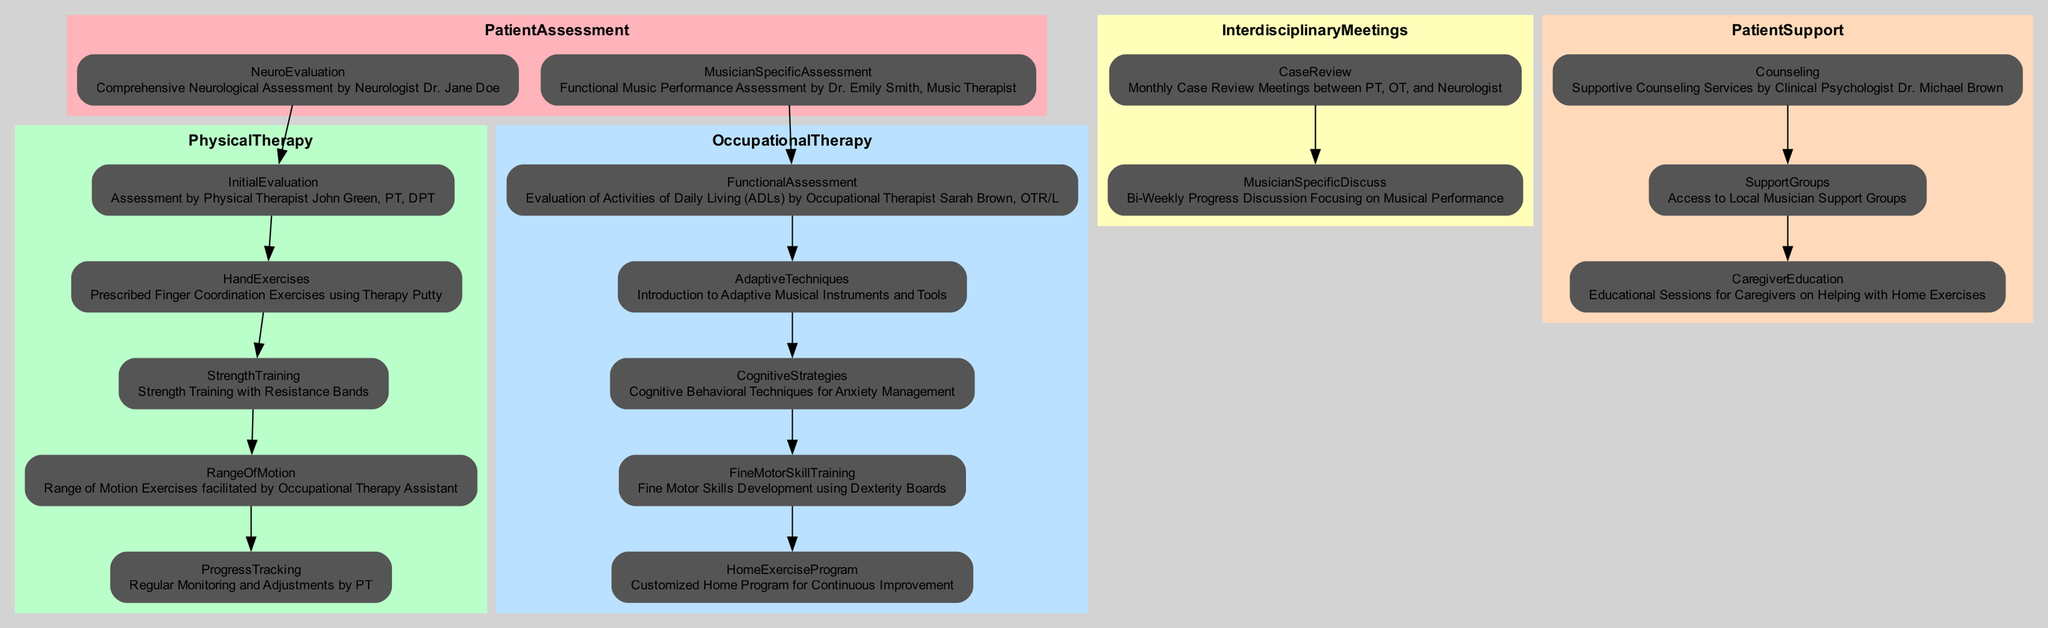What is the first assessment for a patient? The diagram shows the node "NeuroEvaluation" under "PatientAssessment," indicating that the first assessment is a Comprehensive Neurological Assessment by Neurologist Dr. Jane Doe.
Answer: Comprehensive Neurological Assessment by Neurologist Dr. Jane Doe Who conducts the initial evaluation for physical therapy? The diagram identifies "Physical Therapist John Green, PT, DPT" under "InitialEvaluation," showing that he is the one conducting this initial evaluation.
Answer: Physical Therapist John Green, PT, DPT How many total types of therapy are integrated in this pathway? By analyzing the main categories in the diagram, there are three types of therapy: Physical Therapy, Occupational Therapy, and Patient Support. Therefore, the total is three.
Answer: 3 What is the last step in Occupational Therapy? The last node in the Occupational Therapy section is "HomeExerciseProgram," which indicates that it is the final step involved in this therapy.
Answer: Customized Home Program for Continuous Improvement Which professional evaluates activities of daily living? The diagram shows that the "FunctionalAssessment" under "OccupationalTherapy" is evaluated by "Occupational Therapist Sarah Brown, OTR/L."
Answer: Occupational Therapist Sarah Brown, OTR/L What is the focus of the bi-weekly meetings? The node "MusicianSpecificDiscuss" indicates that the bi-weekly meetings focus on Progress Discussion Focusing on Musical Performance.
Answer: Progress Discussion Focusing on Musical Performance Which exercise focuses on finger coordination? The "HandExercises" node in the Physical Therapy section describes the prescribed Finger Coordination Exercises using Therapy Putty, indicating this focus.
Answer: Finger Coordination Exercises using Therapy Putty What type of counseling is provided in Patient Support? Referring to the "Counseling" node under "PatientSupport," it indicates that the Supportive Counseling Services are provided by Clinical Psychologist Dr. Michael Brown.
Answer: Supportive Counseling Services by Clinical Psychologist Dr. Michael Brown 